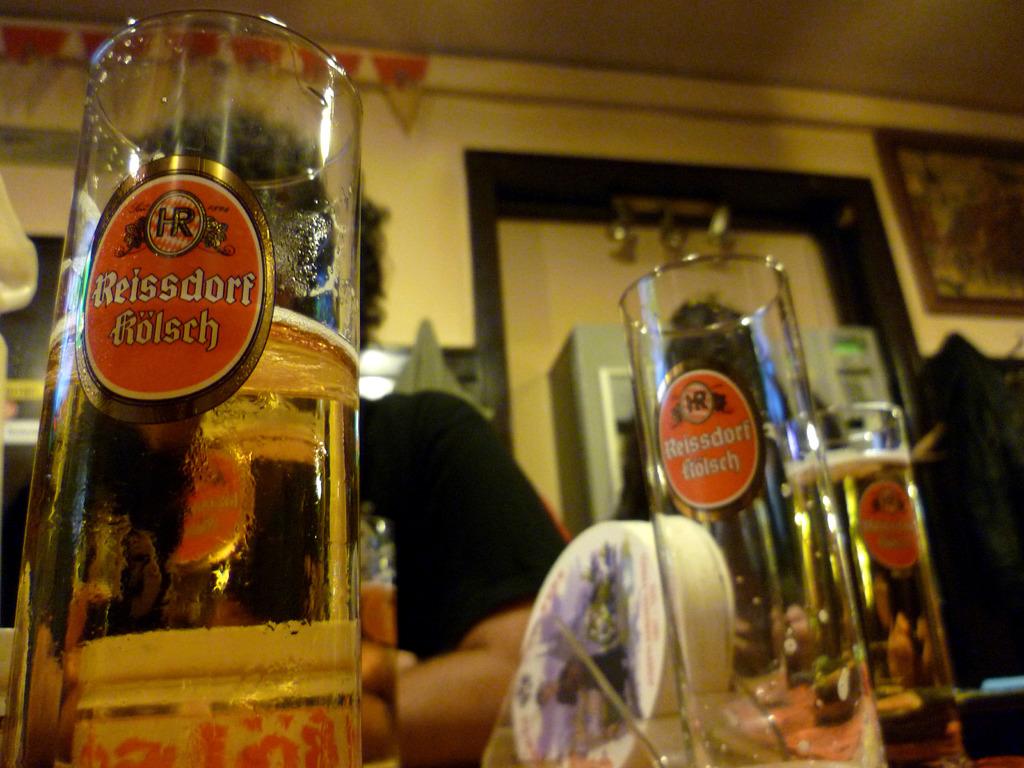Is reissdorf a german beer?
Offer a terse response. Yes. What kind of beer does reissdorf sell?
Your answer should be very brief. Kolsch. 